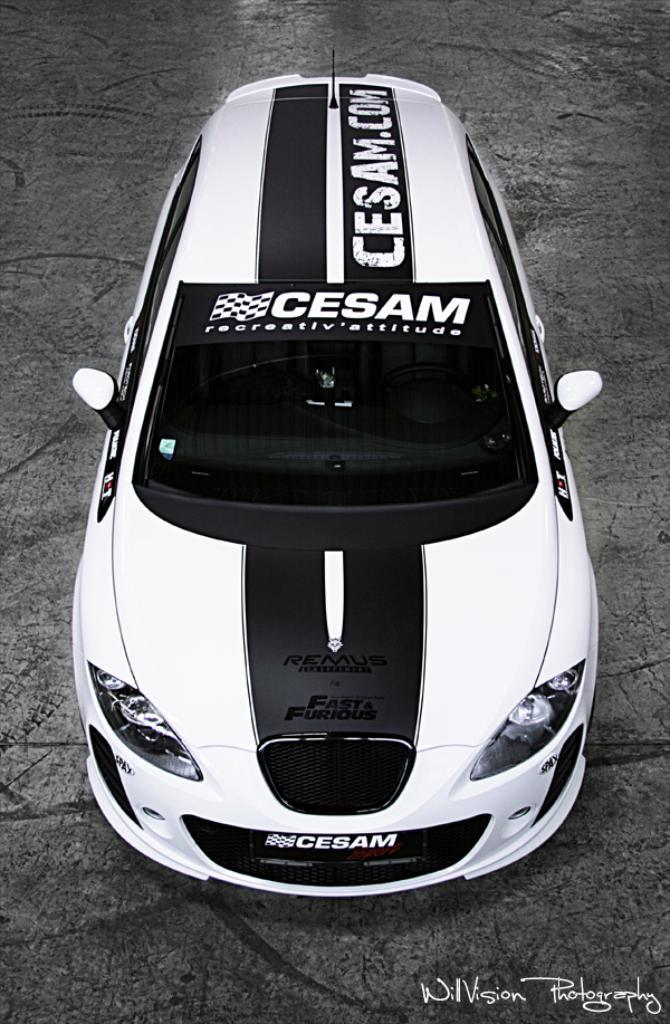What is the color scheme of the image? The image is black and white. What type of vehicle can be seen on the path? There is a sports car on the path. Is there any additional information or branding on the image? Yes, there is a watermark on the image. How many birds are sitting on the cap in the image? There are no birds or caps present in the image. 